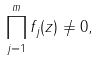Convert formula to latex. <formula><loc_0><loc_0><loc_500><loc_500>\prod _ { j = 1 } ^ { m } f _ { j } ( z ) \ne 0 ,</formula> 